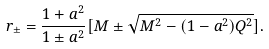<formula> <loc_0><loc_0><loc_500><loc_500>r _ { \pm } = \frac { 1 + a ^ { 2 } } { 1 \pm a ^ { 2 } } [ M \pm \sqrt { M ^ { 2 } - ( 1 - a ^ { 2 } ) Q ^ { 2 } } ] .</formula> 